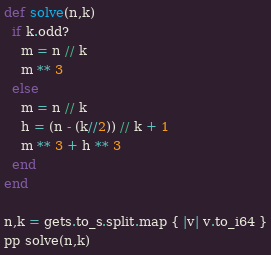<code> <loc_0><loc_0><loc_500><loc_500><_Crystal_>def solve(n,k)
  if k.odd?
    m = n // k
    m ** 3
  else
    m = n // k
    h = (n - (k//2)) // k + 1
    m ** 3 + h ** 3
  end
end

n,k = gets.to_s.split.map { |v| v.to_i64 }
pp solve(n,k)</code> 